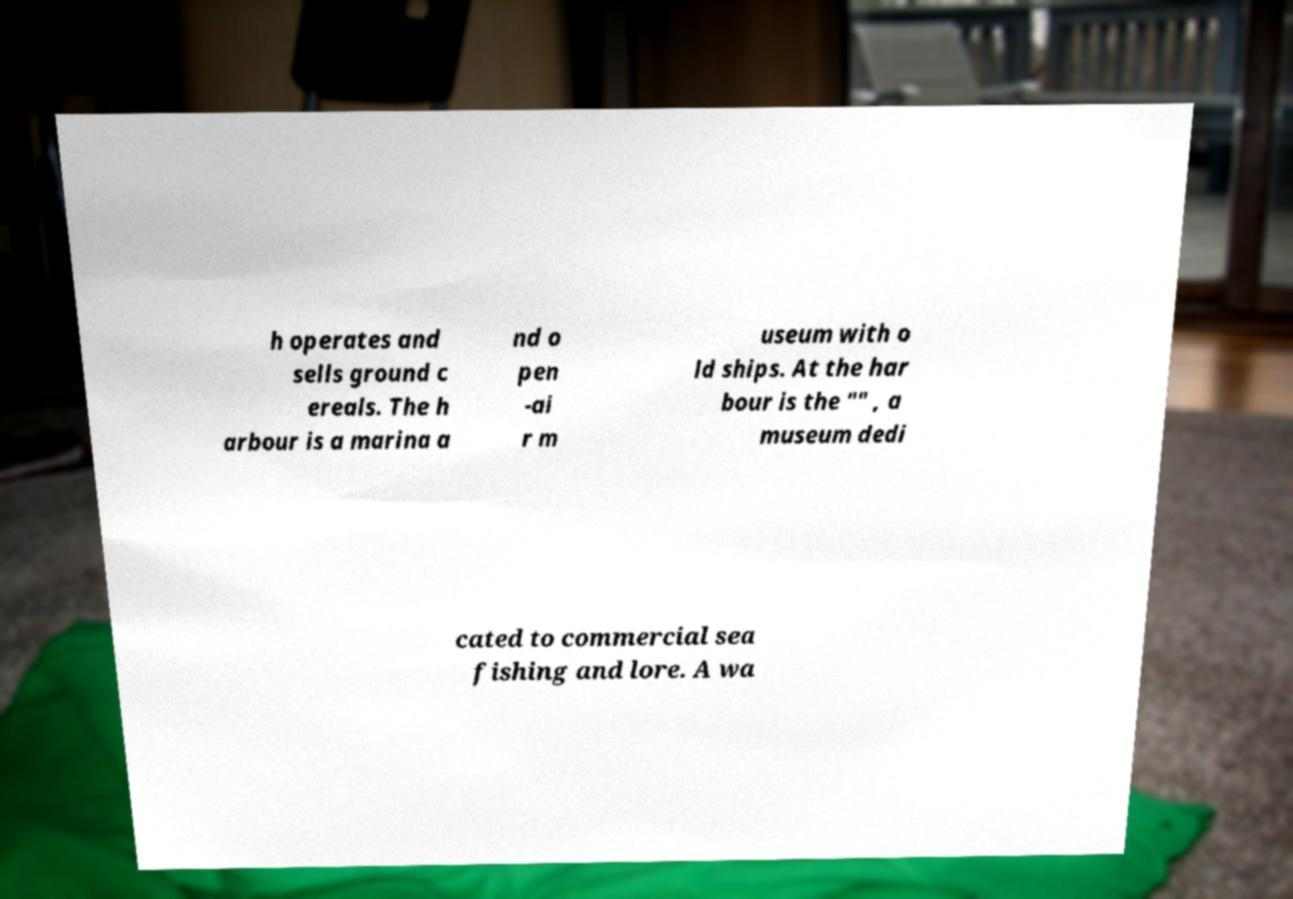Please identify and transcribe the text found in this image. h operates and sells ground c ereals. The h arbour is a marina a nd o pen -ai r m useum with o ld ships. At the har bour is the "" , a museum dedi cated to commercial sea fishing and lore. A wa 